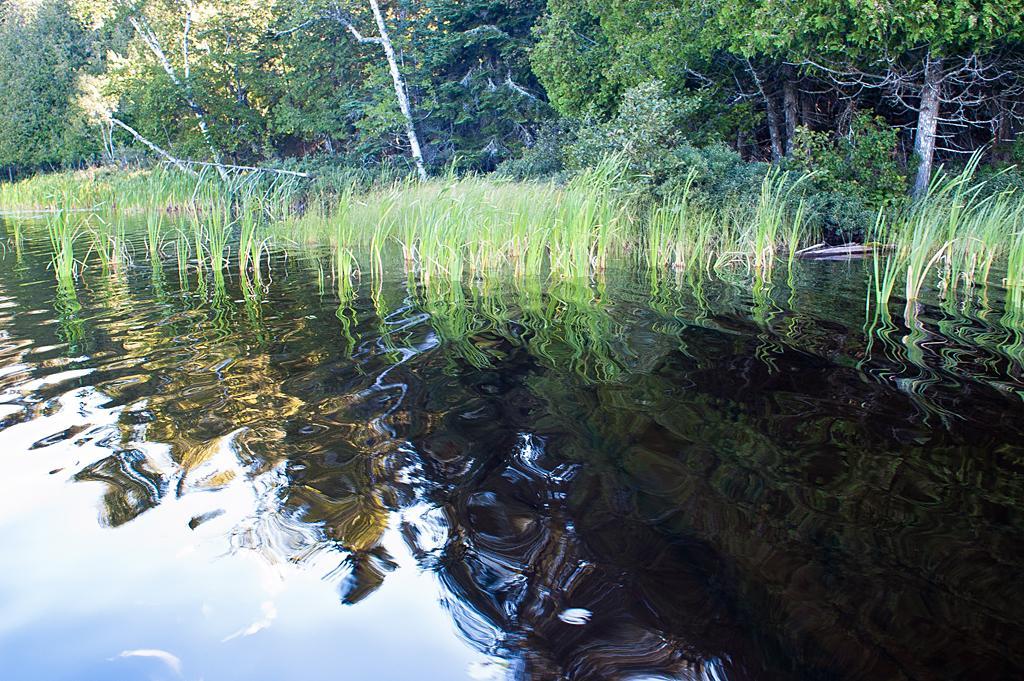Can you describe this image briefly? In this picture there are trees. At the bottom there is grass and there is water and there is reflection of sky on the water. 